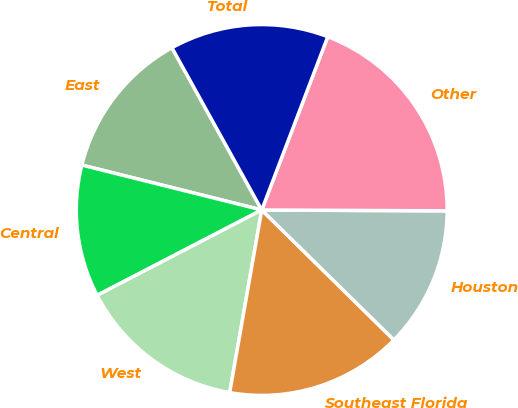Convert chart. <chart><loc_0><loc_0><loc_500><loc_500><pie_chart><fcel>East<fcel>Central<fcel>West<fcel>Southeast Florida<fcel>Houston<fcel>Other<fcel>Total<nl><fcel>13.06%<fcel>11.51%<fcel>14.62%<fcel>15.4%<fcel>12.29%<fcel>19.28%<fcel>13.84%<nl></chart> 